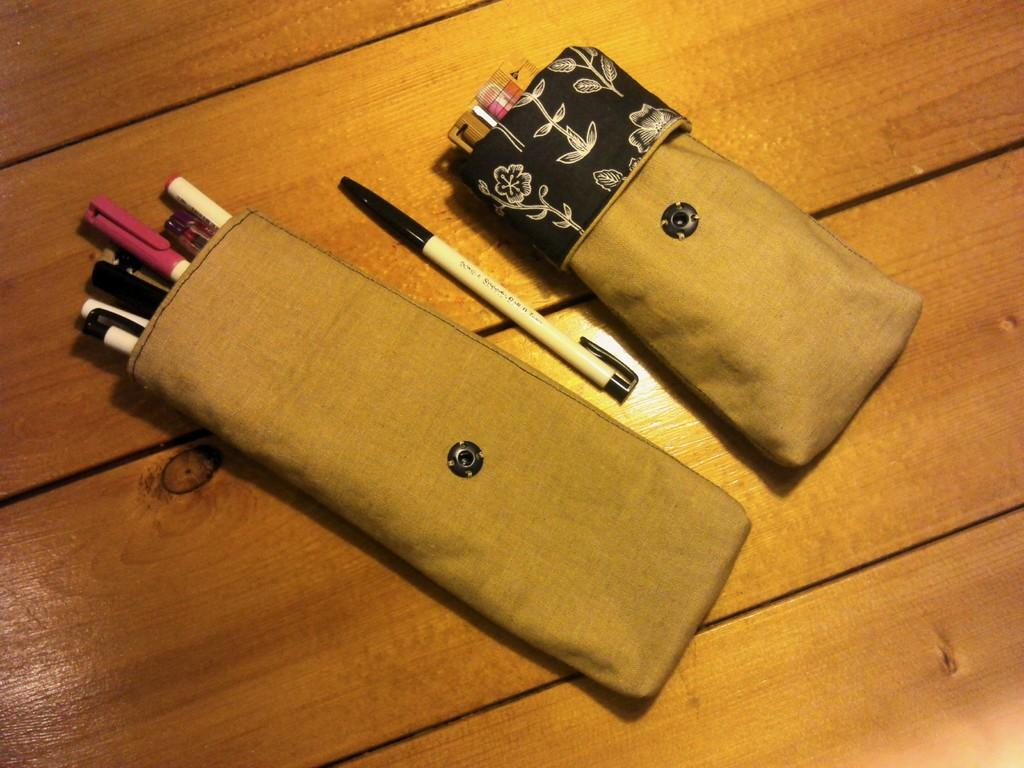What objects are inside the pouches in the image? There are pens in the pouches. What can be seen in the background of the image? There is a wooden board in the background of the image. What type of iron is being used to clean the baby in the image? There is no iron or baby present in the image; it only features pens in pouches and a wooden board in the background. 